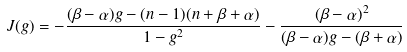Convert formula to latex. <formula><loc_0><loc_0><loc_500><loc_500>J ( g ) = - \frac { ( \beta - \alpha ) g - ( n - 1 ) ( n + \beta + \alpha ) } { 1 - g ^ { 2 } } - \frac { ( \beta - \alpha ) ^ { 2 } } { ( \beta - \alpha ) g - ( \beta + \alpha ) }</formula> 